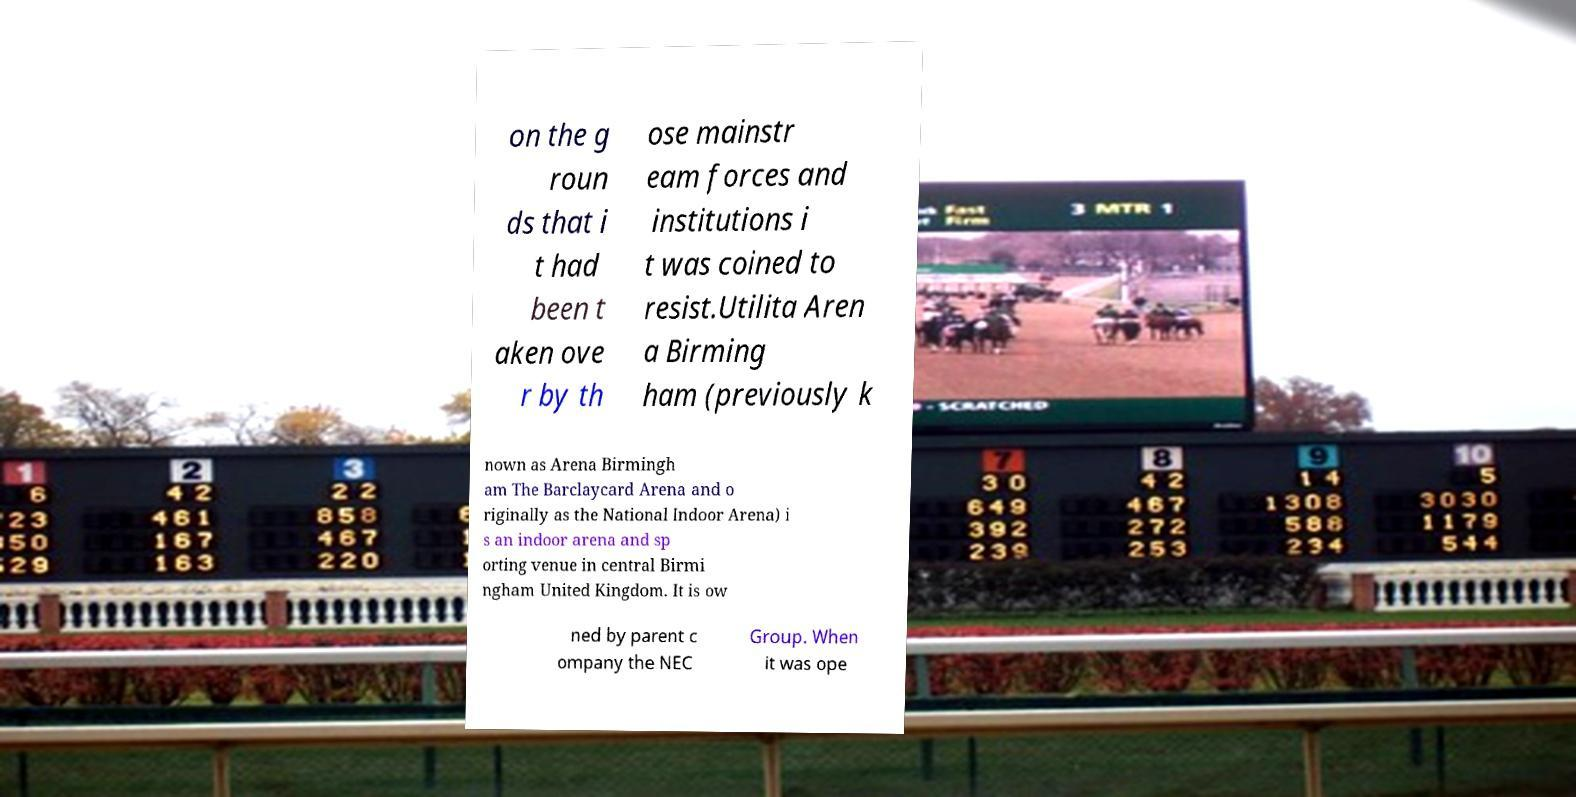Please read and relay the text visible in this image. What does it say? on the g roun ds that i t had been t aken ove r by th ose mainstr eam forces and institutions i t was coined to resist.Utilita Aren a Birming ham (previously k nown as Arena Birmingh am The Barclaycard Arena and o riginally as the National Indoor Arena) i s an indoor arena and sp orting venue in central Birmi ngham United Kingdom. It is ow ned by parent c ompany the NEC Group. When it was ope 